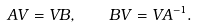Convert formula to latex. <formula><loc_0><loc_0><loc_500><loc_500>A V = V B , \quad B V = V A ^ { - 1 } .</formula> 